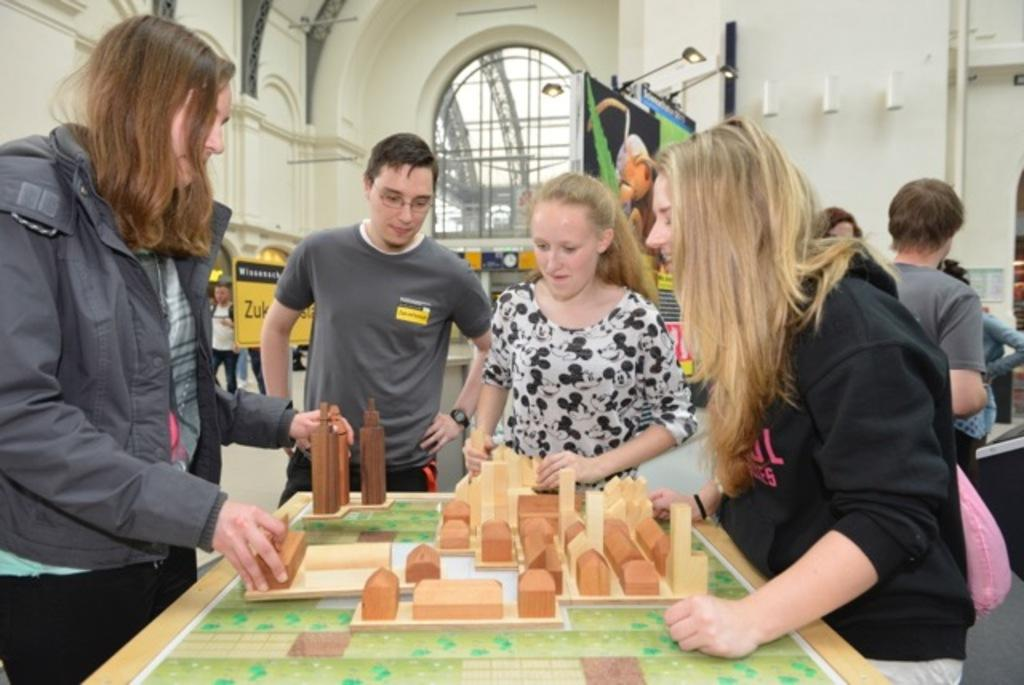How many people are in the image? There are people in the image, but the exact number is not specified. What are the people doing in the image? The people are standing in the image. What type of desk can be seen in the image? There is no desk present in the image. How many oranges are being used by the people in the image? There are no oranges present in the image. 